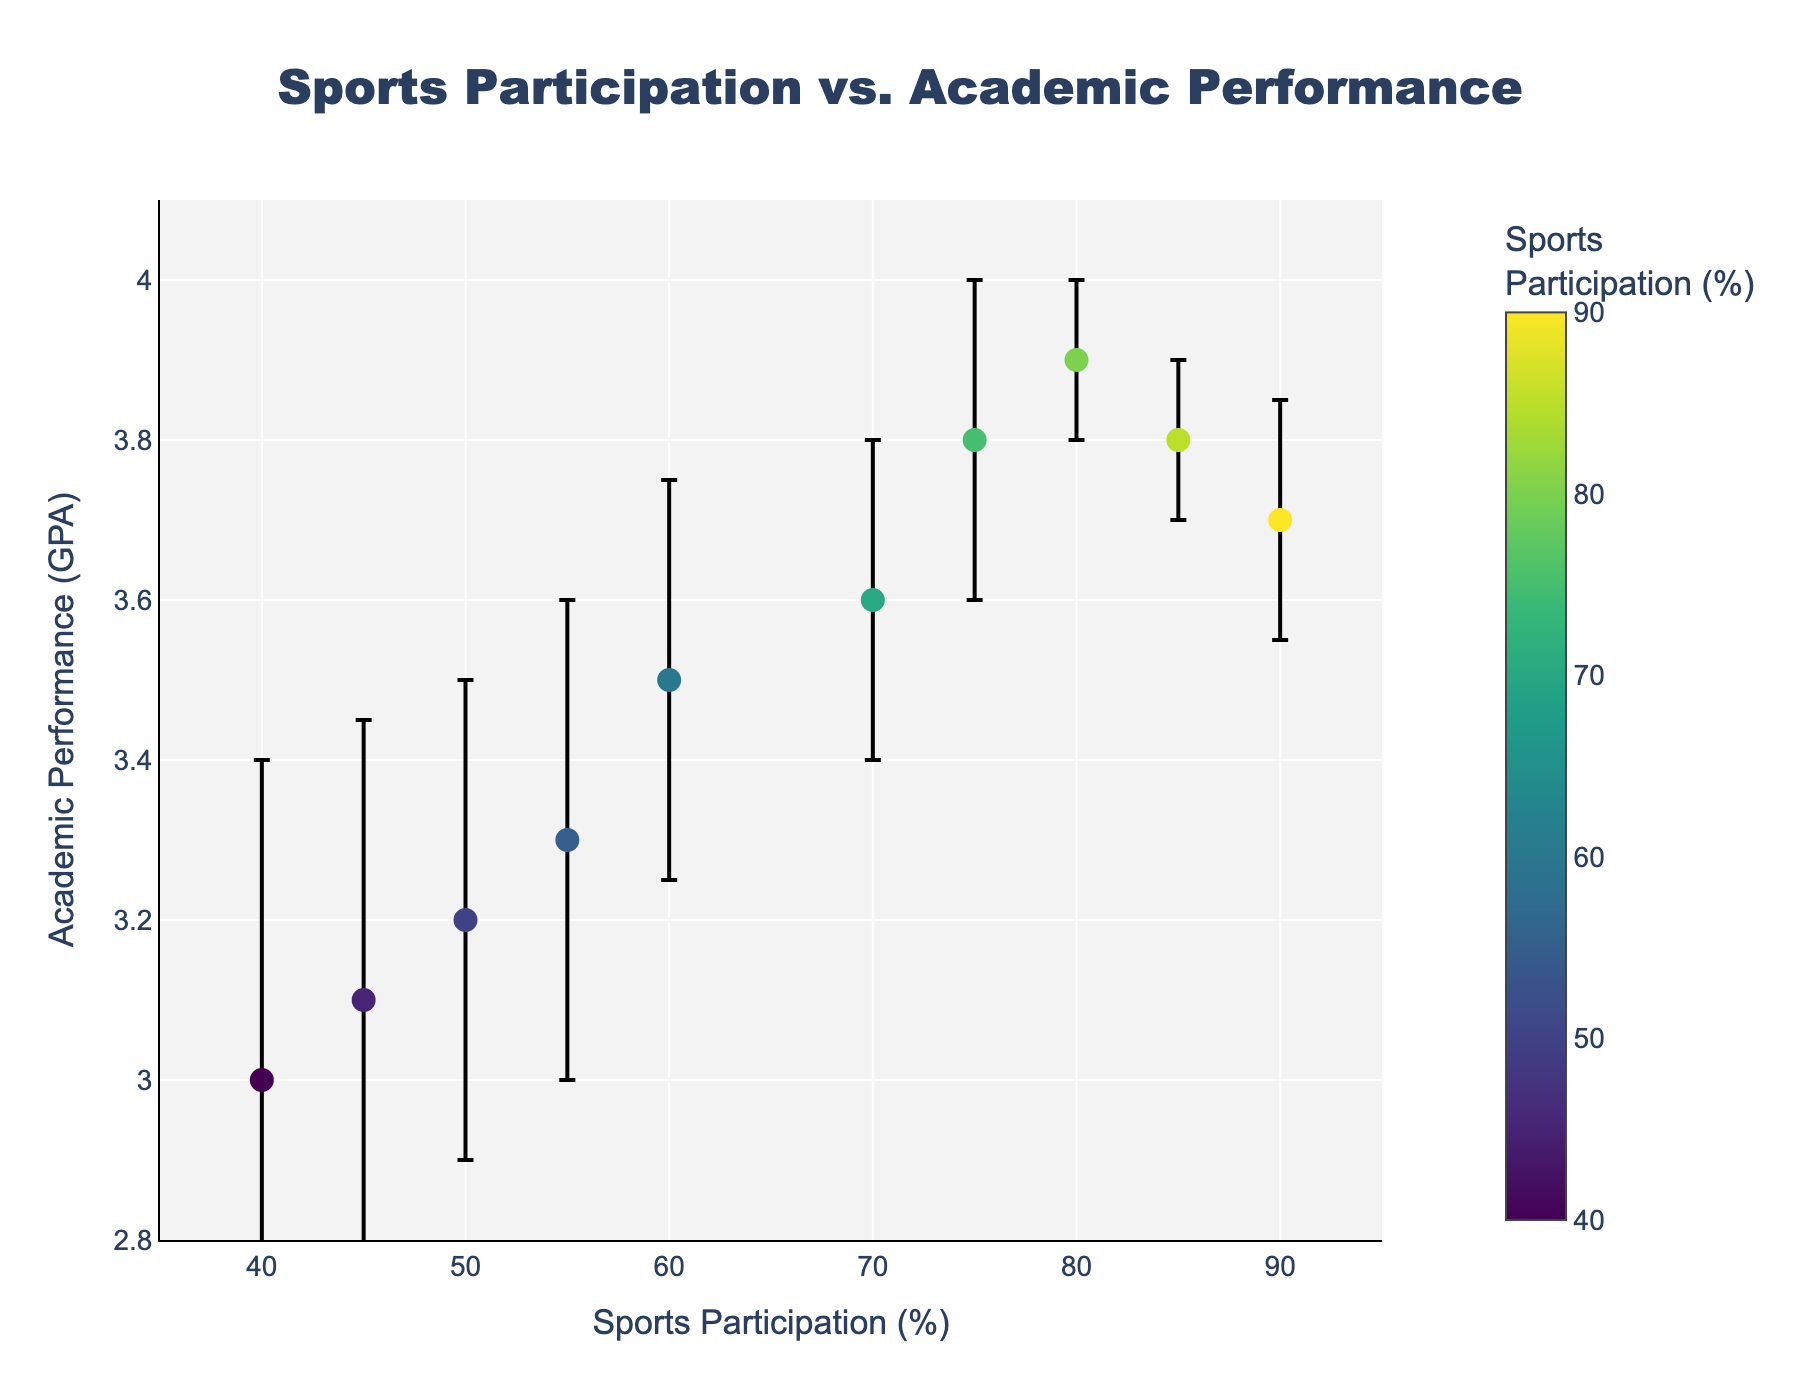What is the title of the plot? The title is located at the top center of the plot and reads "Sports Participation vs. Academic Performance".
Answer: Sports Participation vs. Academic Performance Which student has the highest sports participation percentage? By looking at the x-axis and locating the farthest point to the right, we see that Michael Miller has the highest sports participation percentage at 90%.
Answer: Michael Miller How many data points are shown in the plot? Counting each marker on the plot, there are 10 visible data points, one for each student listed in the data.
Answer: 10 Which student has the largest error bar in academic performance? Observing the error bars of each data point, William Anderson has the largest error bar, showing a variation of +/- 0.4 in GPA.
Answer: William Anderson What's the difference in GPA between Alice Johnson and Robert Brown? Alice Johnson has a GPA of 3.9, and Robert Brown has a GPA of 3.5. The difference is 3.9 - 3.5 = 0.4.
Answer: 0.4 What's the average sports participation percentage of the students who have a GPA of 3.8? Jane Doe and Stephanie Taylor both have a GPA of 3.8. Their sports participation percentages are 75% and 85% respectively. The average is (75 + 85) / 2 = 80%.
Answer: 80% Which student has the lowest GPA and what is that GPA? By locating the lowest point on the y-axis, we find that William Anderson has the lowest GPA at 3.0.
Answer: William Anderson, 3.0 Do students with higher sports participation generally have a higher GPA? Observing the trend in the scatter plot, students with higher sports participation percentages tend to cluster towards higher GPA values, indicating a general positive correlation.
Answer: Yes What range of GPA values are shown in the plot? The GPA values range from the lowest point, 3.0 (William Anderson), to the highest point, 3.9 (Alice Johnson).
Answer: 3.0 to 3.9 